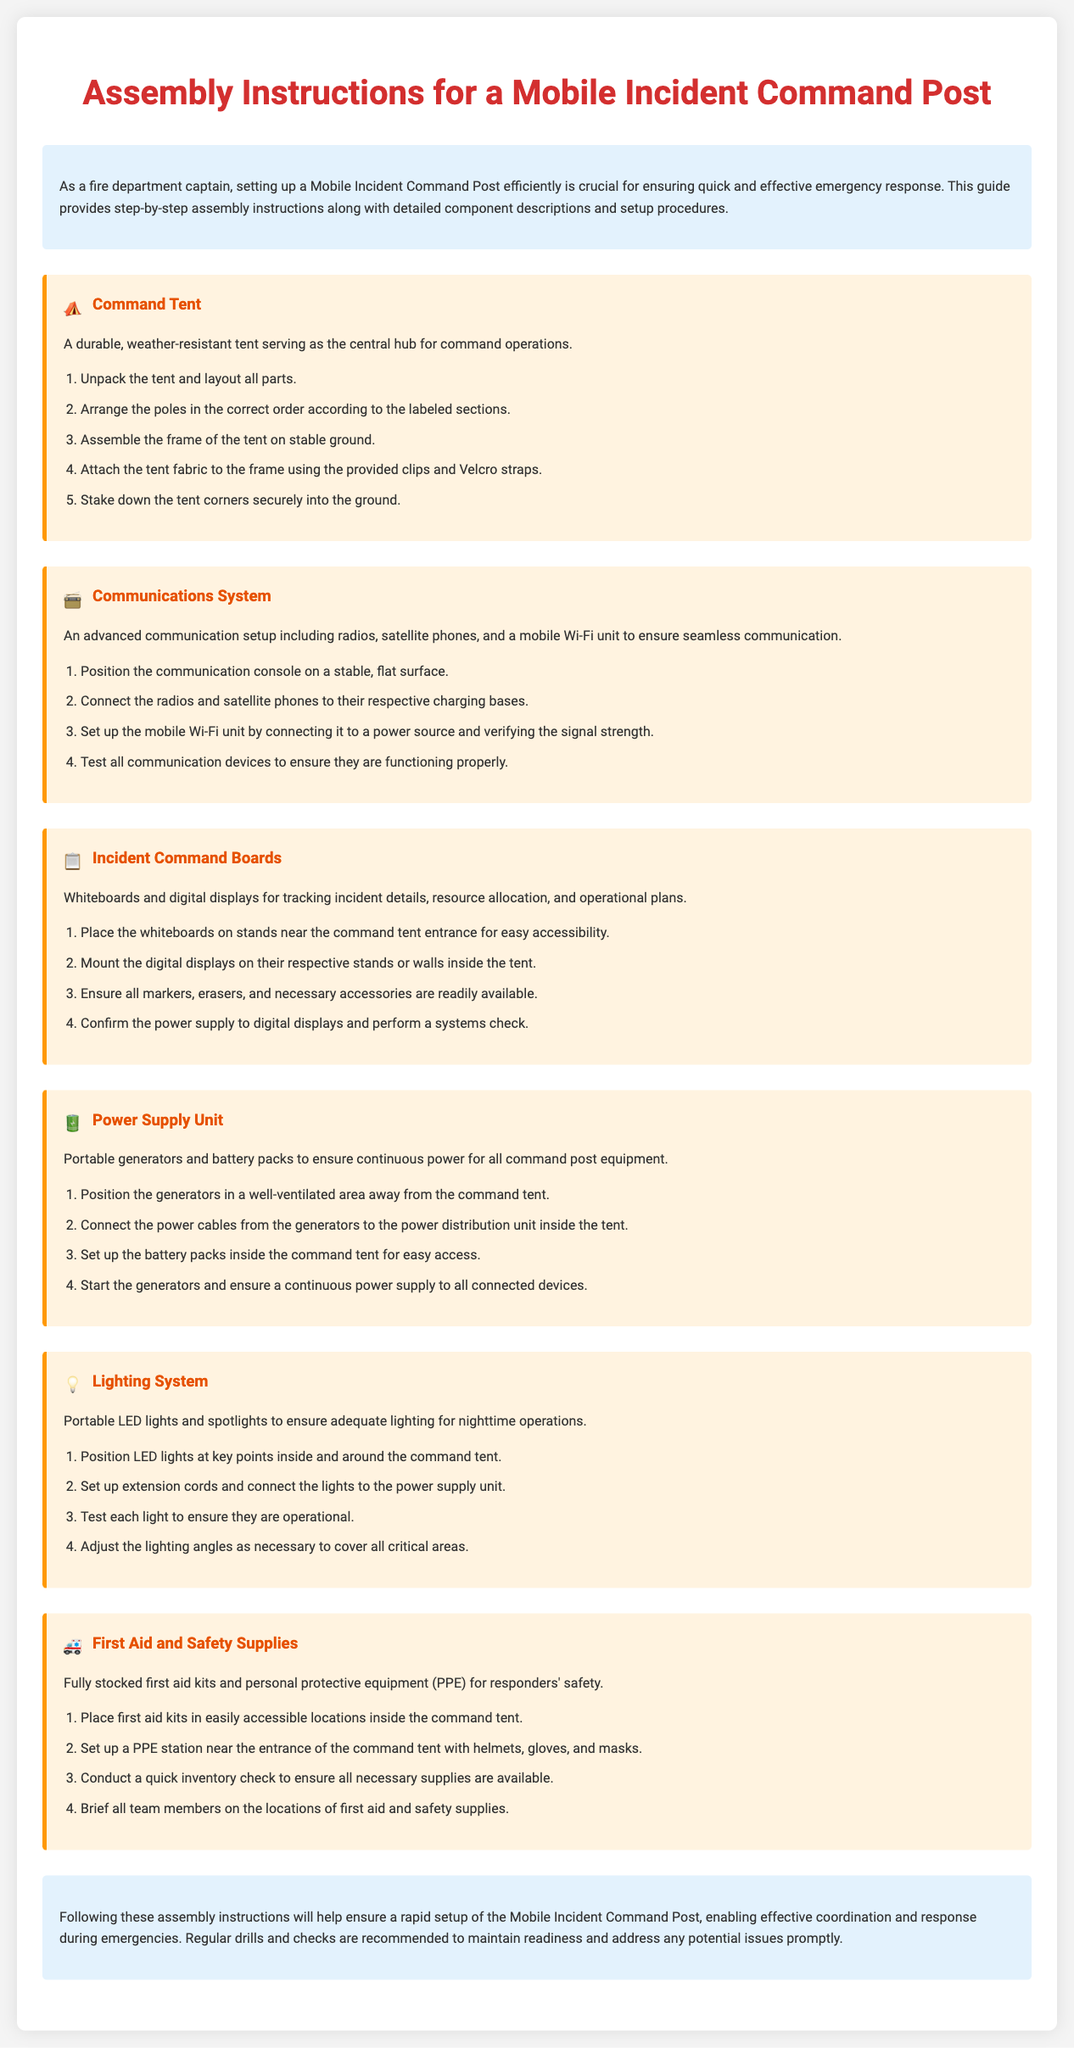What is the title of the document? The title is displayed prominently at the top of the document.
Answer: Assembly Instructions for a Mobile Incident Command Post How many main components are described in the assembly instructions? Each component is clearly identified with its own section in the document.
Answer: Six What is the first step in setting up the Command Tent? The steps are listed under each component, starting with the Command Tent section.
Answer: Unpack the tent and layout all parts What type of supplies are included in the First Aid and Safety Supplies component? The description outlines the essential items included in this section.
Answer: First aid kits and personal protective equipment (PPE) Which component requires testing of communication devices? The section focuses on the setup and testing of a specific system.
Answer: Communications System What should be done with the power supply unit generators? The instructions specify safety and operational guidelines for the generators.
Answer: Position in a well-ventilated area How are the Incident Command Boards positioned? The instructions detail the placement of boards for accessibility.
Answer: Near the command tent entrance What is included in the Lighting System setup? The setup procedure emphasizes the integration of lighting for operational needs.
Answer: Portable LED lights and spotlights What is suggested for maintaining readiness after the assembly? The conclusion provides advice on ongoing preparedness activities.
Answer: Regular drills and checks 